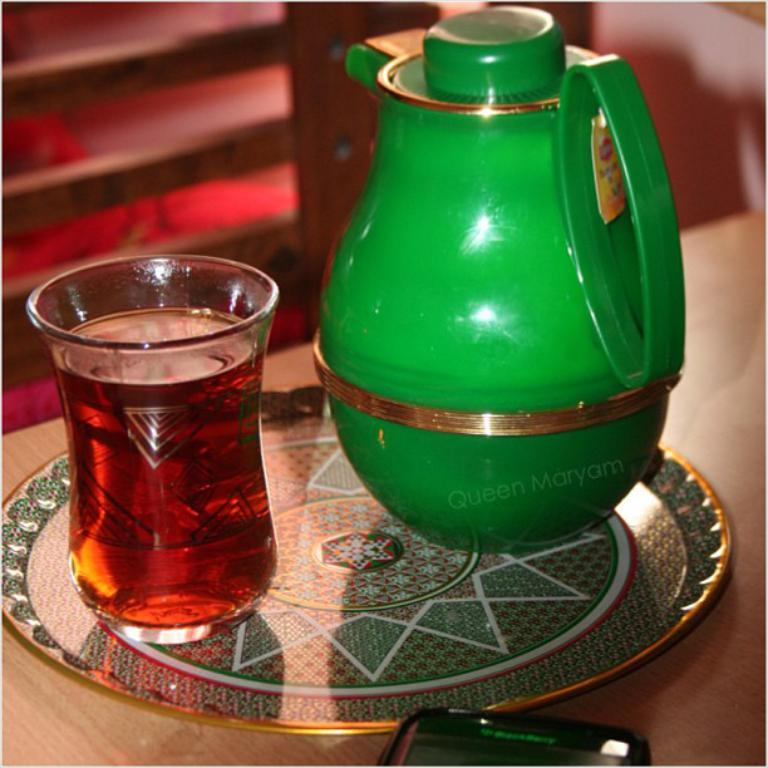What color is the kettle in the image? The kettle in the image is green. What objects are placed on top of each other in the image? A glass is kept in a plate in the image. Where is the mobile located in the image? The mobile is at the bottom of the image. What type of jeans is the cow wearing in the image? There is no cow or jeans present in the image. How many pipes can be seen connected to the kettle in the image? There are no pipes connected to the kettle in the image. 